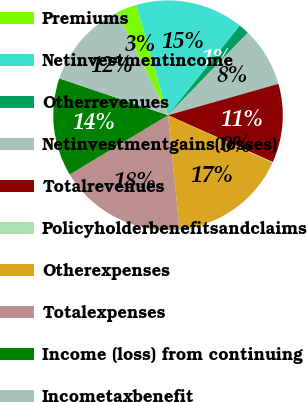<chart> <loc_0><loc_0><loc_500><loc_500><pie_chart><fcel>Premiums<fcel>Netinvestmentincome<fcel>Otherrevenues<fcel>Netinvestmentgains(losses)<fcel>Totalrevenues<fcel>Policyholderbenefitsandclaims<fcel>Otherexpenses<fcel>Totalexpenses<fcel>Income (loss) from continuing<fcel>Incometaxbenefit<nl><fcel>2.86%<fcel>15.22%<fcel>1.49%<fcel>8.35%<fcel>11.1%<fcel>0.11%<fcel>16.59%<fcel>17.96%<fcel>13.84%<fcel>12.47%<nl></chart> 